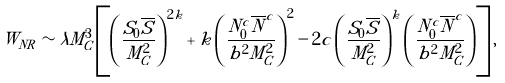<formula> <loc_0><loc_0><loc_500><loc_500>W _ { N R } \sim \lambda M _ { C } ^ { 3 } \left [ \left ( \frac { S _ { 0 } { \overline { S } } } { M _ { C } ^ { 2 } } \right ) ^ { 2 k } + k \left ( \frac { N _ { 0 } ^ { c } { \overline { N } ^ { c } } } { b ^ { 2 } M _ { C } ^ { 2 } } \right ) ^ { 2 } - 2 c \left ( \frac { S _ { 0 } { \overline { S } } } { M _ { C } ^ { 2 } } \right ) ^ { k } \left ( \frac { N _ { 0 } ^ { c } { \overline { N } ^ { c } } } { b ^ { 2 } M _ { C } ^ { 2 } } \right ) \right ] ,</formula> 